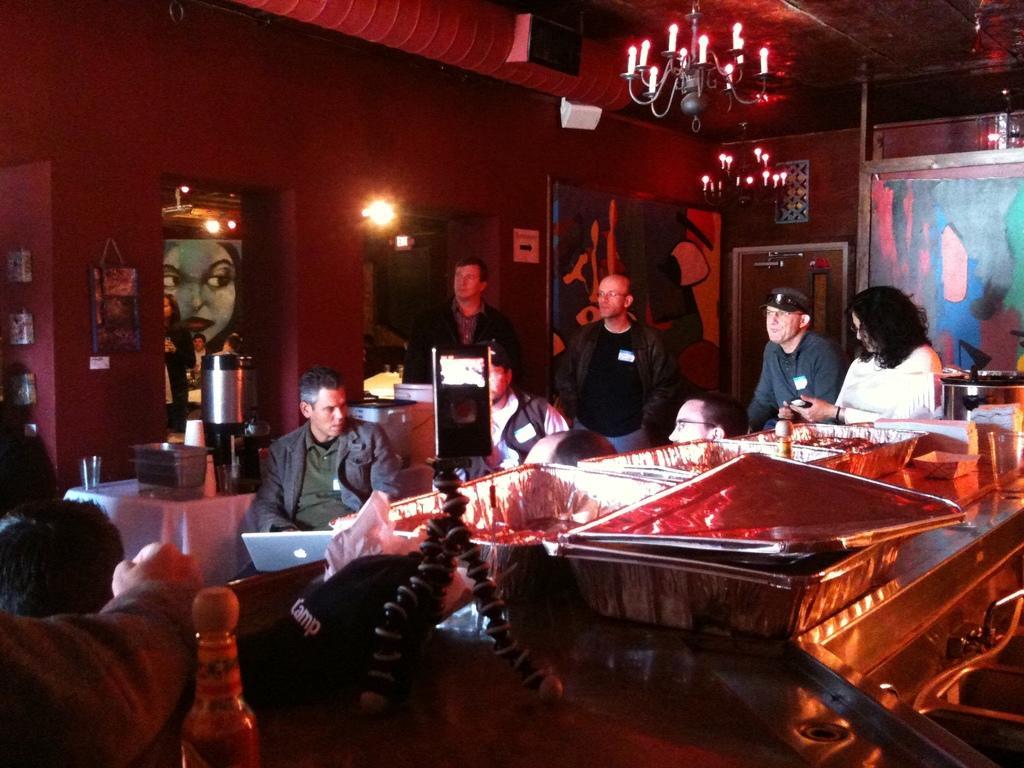Describe this image in one or two sentences. Here we can see some are sitting on the chair and some are standing, and in front here is the table and some objects on it, and here is the wall, and here is the light, and at above her is the chandelier. 